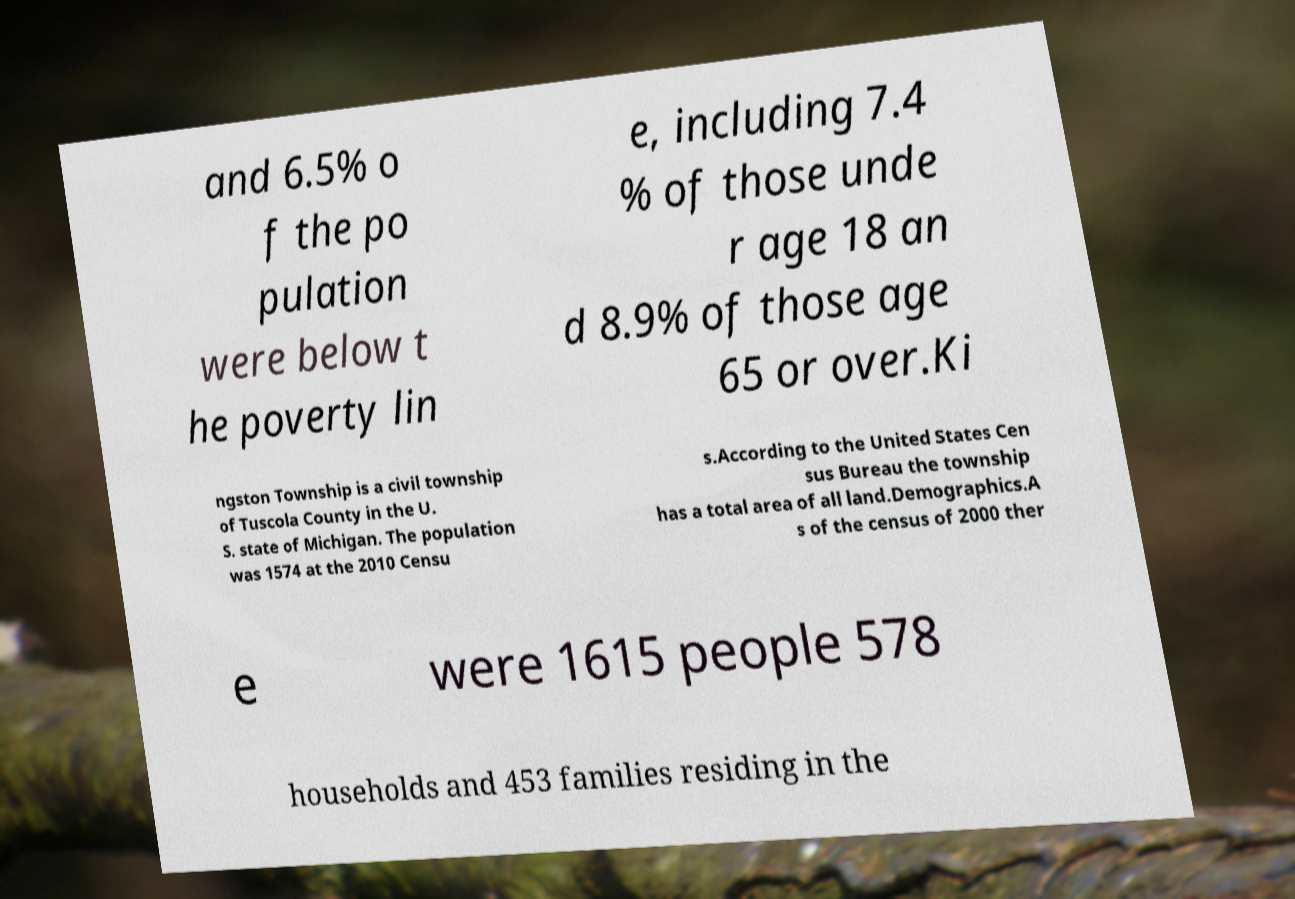Can you read and provide the text displayed in the image?This photo seems to have some interesting text. Can you extract and type it out for me? and 6.5% o f the po pulation were below t he poverty lin e, including 7.4 % of those unde r age 18 an d 8.9% of those age 65 or over.Ki ngston Township is a civil township of Tuscola County in the U. S. state of Michigan. The population was 1574 at the 2010 Censu s.According to the United States Cen sus Bureau the township has a total area of all land.Demographics.A s of the census of 2000 ther e were 1615 people 578 households and 453 families residing in the 